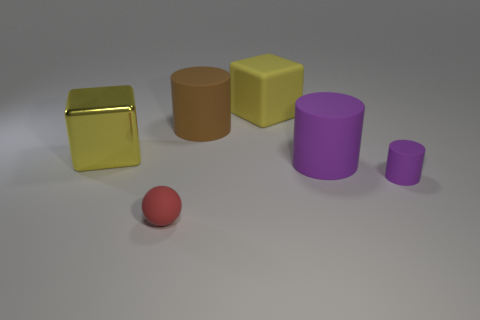How many tiny cyan things have the same material as the large brown cylinder?
Your answer should be very brief. 0. There is a sphere to the right of the shiny cube that is in front of the big yellow rubber object; what size is it?
Your answer should be compact. Small. There is a large rubber object that is both on the right side of the big brown cylinder and in front of the matte cube; what is its color?
Make the answer very short. Purple. Is the tiny purple object the same shape as the brown rubber thing?
Ensure brevity in your answer.  Yes. What is the shape of the big purple matte object that is on the right side of the large yellow metal thing to the left of the brown cylinder?
Your answer should be compact. Cylinder. There is a metal thing; is its shape the same as the big object in front of the metallic cube?
Make the answer very short. No. What is the color of the other rubber cylinder that is the same size as the brown rubber cylinder?
Your answer should be very brief. Purple. Is the number of large brown matte objects that are on the right side of the large brown object less than the number of big cubes that are left of the rubber block?
Offer a terse response. Yes. What is the shape of the tiny rubber object on the right side of the red object that is in front of the yellow block that is left of the brown rubber object?
Your answer should be very brief. Cylinder. Do the large rubber object in front of the brown object and the tiny thing that is on the right side of the red matte ball have the same color?
Provide a succinct answer. Yes. 